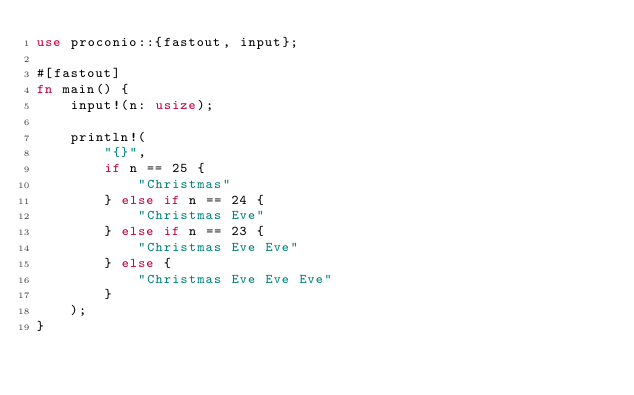Convert code to text. <code><loc_0><loc_0><loc_500><loc_500><_Rust_>use proconio::{fastout, input};

#[fastout]
fn main() {
    input!(n: usize);

    println!(
        "{}",
        if n == 25 {
            "Christmas"
        } else if n == 24 {
            "Christmas Eve"
        } else if n == 23 {
            "Christmas Eve Eve"
        } else {
            "Christmas Eve Eve Eve"
        }
    );
}
</code> 